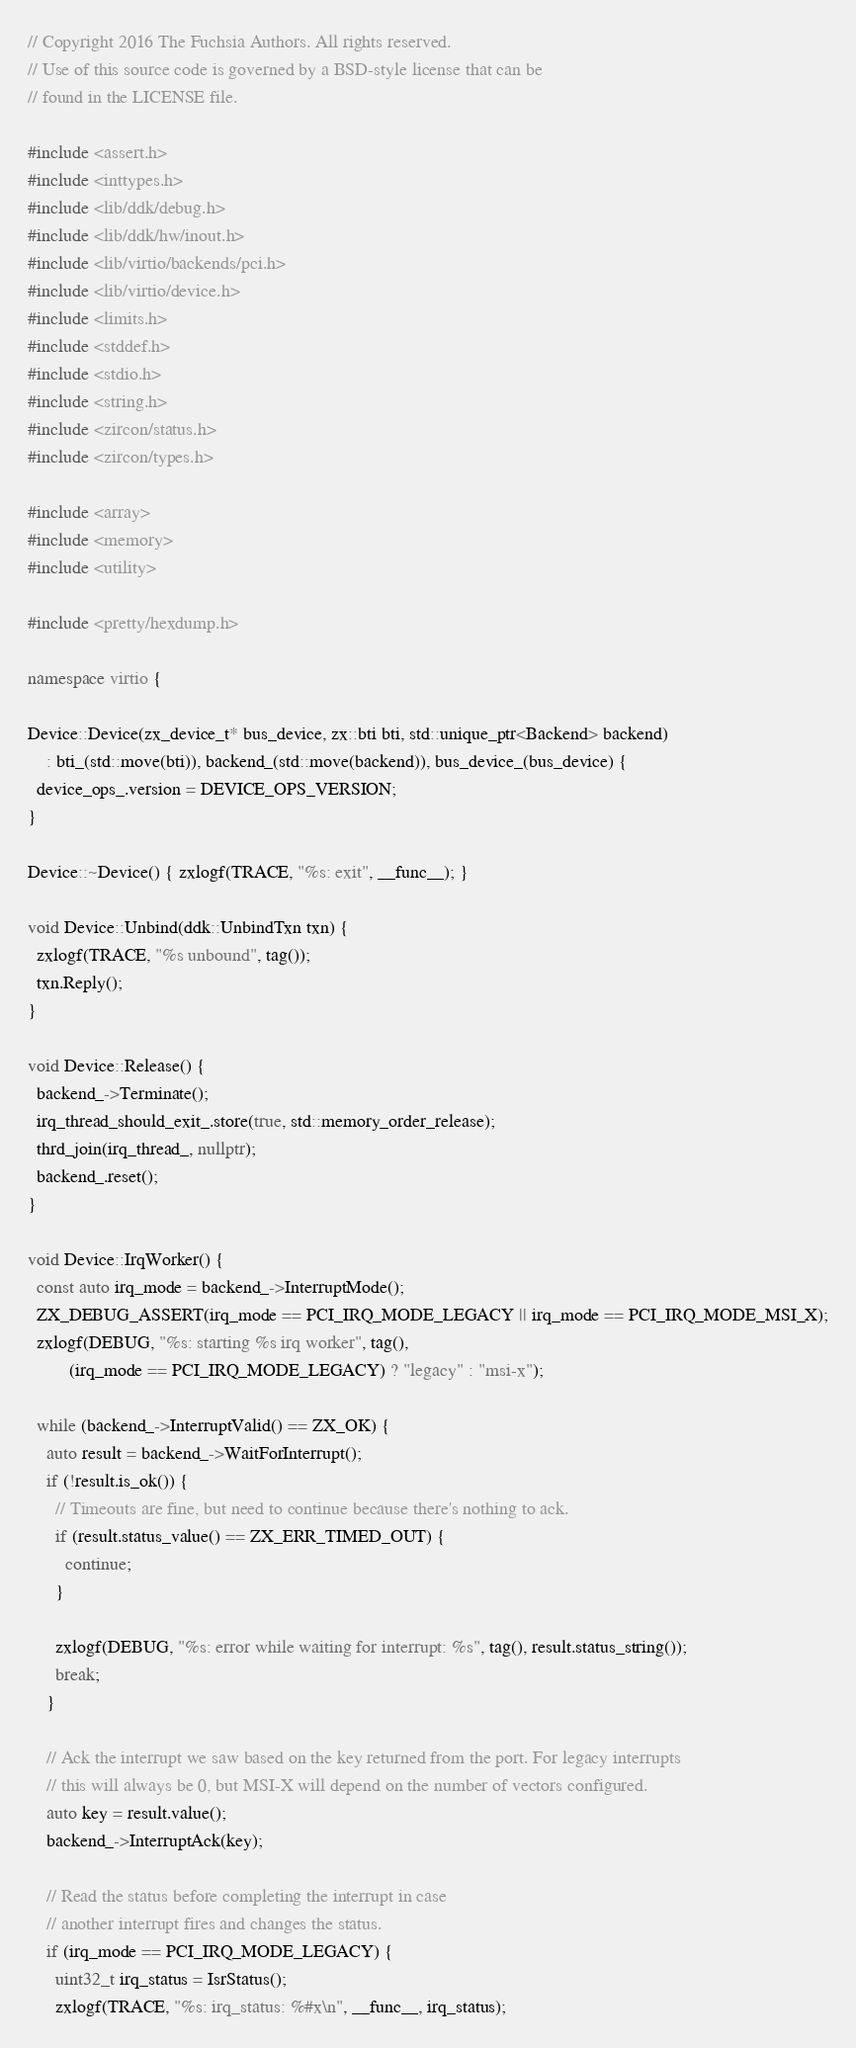Convert code to text. <code><loc_0><loc_0><loc_500><loc_500><_C++_>// Copyright 2016 The Fuchsia Authors. All rights reserved.
// Use of this source code is governed by a BSD-style license that can be
// found in the LICENSE file.

#include <assert.h>
#include <inttypes.h>
#include <lib/ddk/debug.h>
#include <lib/ddk/hw/inout.h>
#include <lib/virtio/backends/pci.h>
#include <lib/virtio/device.h>
#include <limits.h>
#include <stddef.h>
#include <stdio.h>
#include <string.h>
#include <zircon/status.h>
#include <zircon/types.h>

#include <array>
#include <memory>
#include <utility>

#include <pretty/hexdump.h>

namespace virtio {

Device::Device(zx_device_t* bus_device, zx::bti bti, std::unique_ptr<Backend> backend)
    : bti_(std::move(bti)), backend_(std::move(backend)), bus_device_(bus_device) {
  device_ops_.version = DEVICE_OPS_VERSION;
}

Device::~Device() { zxlogf(TRACE, "%s: exit", __func__); }

void Device::Unbind(ddk::UnbindTxn txn) {
  zxlogf(TRACE, "%s unbound", tag());
  txn.Reply();
}

void Device::Release() {
  backend_->Terminate();
  irq_thread_should_exit_.store(true, std::memory_order_release);
  thrd_join(irq_thread_, nullptr);
  backend_.reset();
}

void Device::IrqWorker() {
  const auto irq_mode = backend_->InterruptMode();
  ZX_DEBUG_ASSERT(irq_mode == PCI_IRQ_MODE_LEGACY || irq_mode == PCI_IRQ_MODE_MSI_X);
  zxlogf(DEBUG, "%s: starting %s irq worker", tag(),
         (irq_mode == PCI_IRQ_MODE_LEGACY) ? "legacy" : "msi-x");

  while (backend_->InterruptValid() == ZX_OK) {
    auto result = backend_->WaitForInterrupt();
    if (!result.is_ok()) {
      // Timeouts are fine, but need to continue because there's nothing to ack.
      if (result.status_value() == ZX_ERR_TIMED_OUT) {
        continue;
      }

      zxlogf(DEBUG, "%s: error while waiting for interrupt: %s", tag(), result.status_string());
      break;
    }

    // Ack the interrupt we saw based on the key returned from the port. For legacy interrupts
    // this will always be 0, but MSI-X will depend on the number of vectors configured.
    auto key = result.value();
    backend_->InterruptAck(key);

    // Read the status before completing the interrupt in case
    // another interrupt fires and changes the status.
    if (irq_mode == PCI_IRQ_MODE_LEGACY) {
      uint32_t irq_status = IsrStatus();
      zxlogf(TRACE, "%s: irq_status: %#x\n", __func__, irq_status);
</code> 